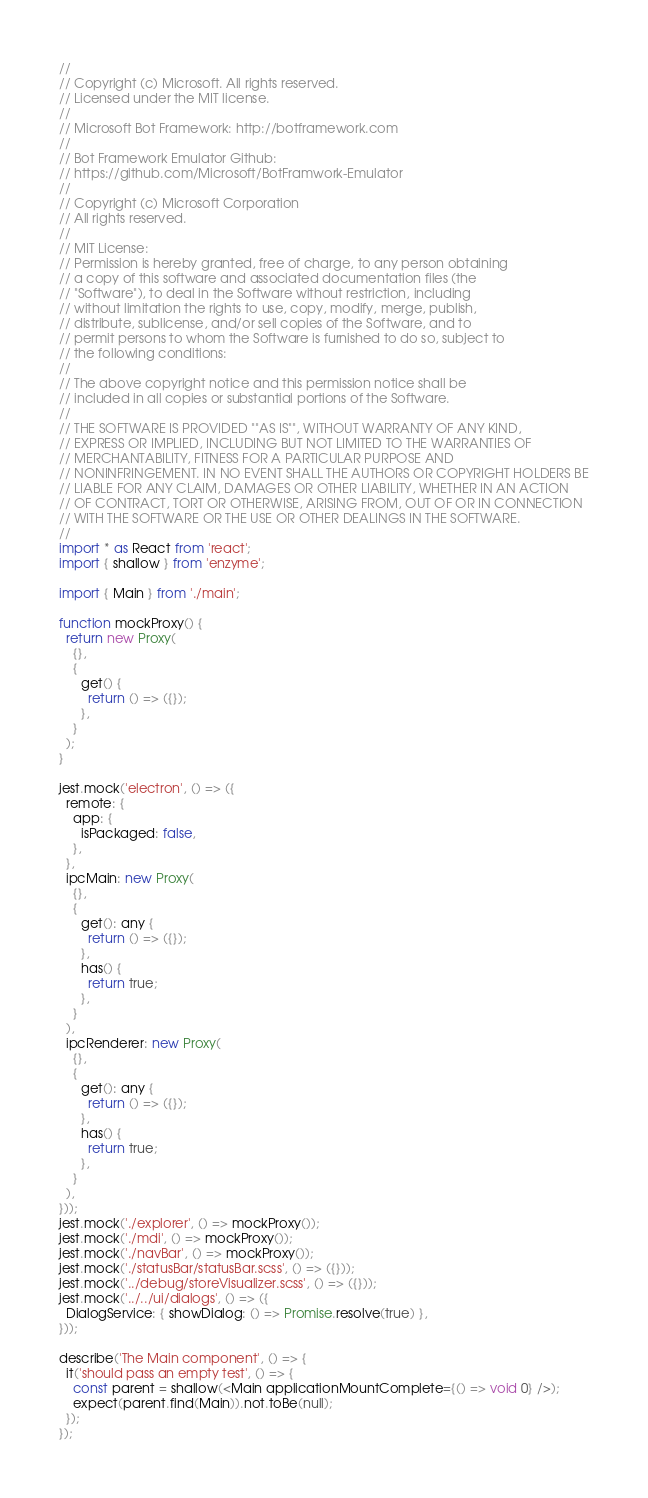<code> <loc_0><loc_0><loc_500><loc_500><_TypeScript_>//
// Copyright (c) Microsoft. All rights reserved.
// Licensed under the MIT license.
//
// Microsoft Bot Framework: http://botframework.com
//
// Bot Framework Emulator Github:
// https://github.com/Microsoft/BotFramwork-Emulator
//
// Copyright (c) Microsoft Corporation
// All rights reserved.
//
// MIT License:
// Permission is hereby granted, free of charge, to any person obtaining
// a copy of this software and associated documentation files (the
// "Software"), to deal in the Software without restriction, including
// without limitation the rights to use, copy, modify, merge, publish,
// distribute, sublicense, and/or sell copies of the Software, and to
// permit persons to whom the Software is furnished to do so, subject to
// the following conditions:
//
// The above copyright notice and this permission notice shall be
// included in all copies or substantial portions of the Software.
//
// THE SOFTWARE IS PROVIDED ""AS IS"", WITHOUT WARRANTY OF ANY KIND,
// EXPRESS OR IMPLIED, INCLUDING BUT NOT LIMITED TO THE WARRANTIES OF
// MERCHANTABILITY, FITNESS FOR A PARTICULAR PURPOSE AND
// NONINFRINGEMENT. IN NO EVENT SHALL THE AUTHORS OR COPYRIGHT HOLDERS BE
// LIABLE FOR ANY CLAIM, DAMAGES OR OTHER LIABILITY, WHETHER IN AN ACTION
// OF CONTRACT, TORT OR OTHERWISE, ARISING FROM, OUT OF OR IN CONNECTION
// WITH THE SOFTWARE OR THE USE OR OTHER DEALINGS IN THE SOFTWARE.
//
import * as React from 'react';
import { shallow } from 'enzyme';

import { Main } from './main';

function mockProxy() {
  return new Proxy(
    {},
    {
      get() {
        return () => ({});
      },
    }
  );
}

jest.mock('electron', () => ({
  remote: {
    app: {
      isPackaged: false,
    },
  },
  ipcMain: new Proxy(
    {},
    {
      get(): any {
        return () => ({});
      },
      has() {
        return true;
      },
    }
  ),
  ipcRenderer: new Proxy(
    {},
    {
      get(): any {
        return () => ({});
      },
      has() {
        return true;
      },
    }
  ),
}));
jest.mock('./explorer', () => mockProxy());
jest.mock('./mdi', () => mockProxy());
jest.mock('./navBar', () => mockProxy());
jest.mock('./statusBar/statusBar.scss', () => ({}));
jest.mock('../debug/storeVisualizer.scss', () => ({}));
jest.mock('../../ui/dialogs', () => ({
  DialogService: { showDialog: () => Promise.resolve(true) },
}));

describe('The Main component', () => {
  it('should pass an empty test', () => {
    const parent = shallow(<Main applicationMountComplete={() => void 0} />);
    expect(parent.find(Main)).not.toBe(null);
  });
});
</code> 